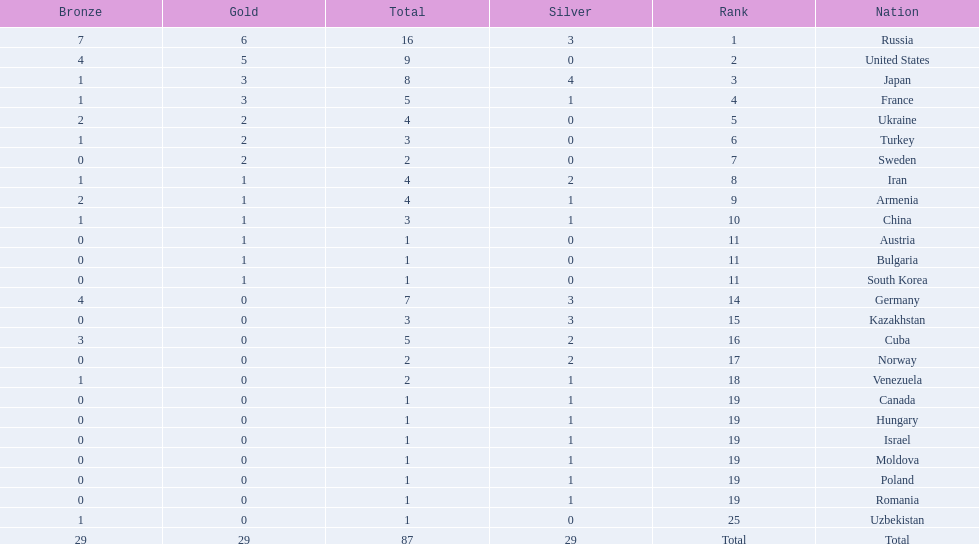How many countries competed? Israel. How many total medals did russia win? 16. What country won only 1 medal? Uzbekistan. 